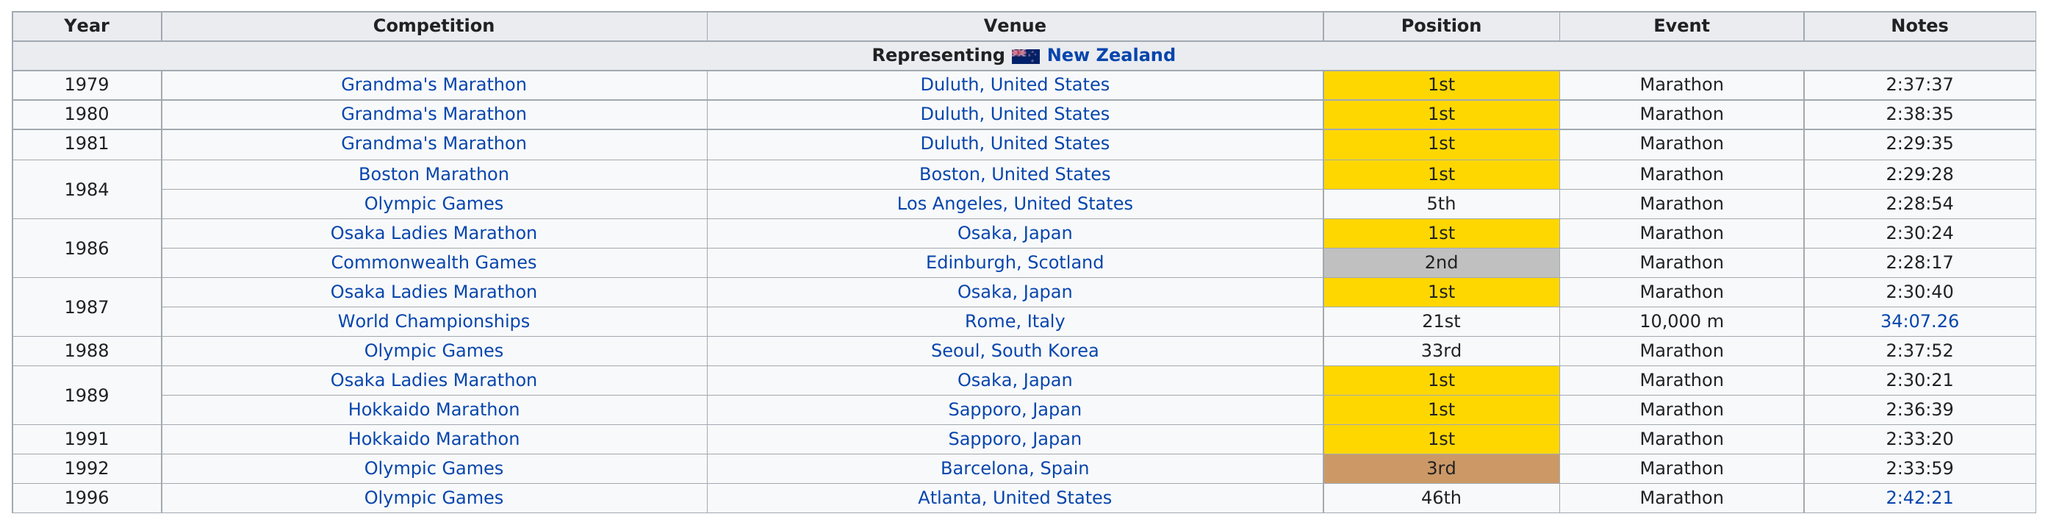Outline some significant characteristics in this image. The name of the venue after Rome, Italy was Seoul, South Korea. Three consecutive Grandma's Marathons were raced. Lorraine Moller set the overall best time of 2 hours and 28 minutes and 17 seconds. Lorraine Moller competed in a total of 5 marathons in Japan. In 1984, the Olympic Games marathon was faster than the Olympic Games held in 1988. 